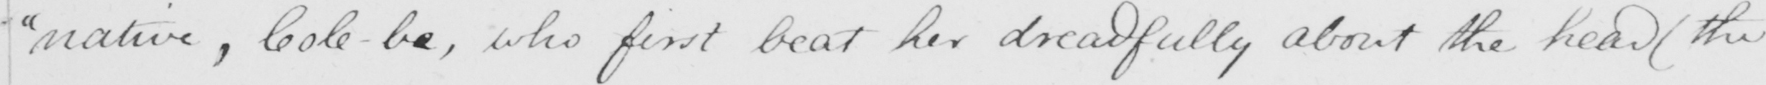Can you tell me what this handwritten text says? "native, Cole-be , who first beat her dreadfully about the head (the 